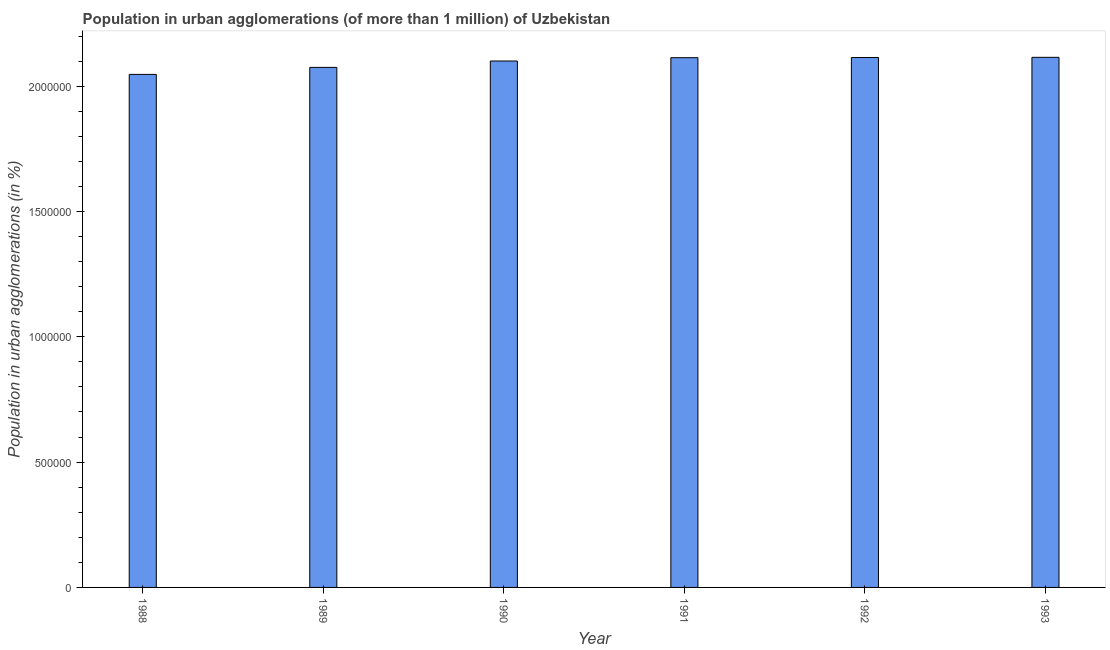Does the graph contain grids?
Ensure brevity in your answer.  No. What is the title of the graph?
Offer a terse response. Population in urban agglomerations (of more than 1 million) of Uzbekistan. What is the label or title of the Y-axis?
Keep it short and to the point. Population in urban agglomerations (in %). What is the population in urban agglomerations in 1988?
Keep it short and to the point. 2.05e+06. Across all years, what is the maximum population in urban agglomerations?
Your answer should be very brief. 2.12e+06. Across all years, what is the minimum population in urban agglomerations?
Your response must be concise. 2.05e+06. What is the sum of the population in urban agglomerations?
Provide a succinct answer. 1.26e+07. What is the difference between the population in urban agglomerations in 1991 and 1992?
Give a very brief answer. -700. What is the average population in urban agglomerations per year?
Offer a terse response. 2.09e+06. What is the median population in urban agglomerations?
Ensure brevity in your answer.  2.11e+06. In how many years, is the population in urban agglomerations greater than 1600000 %?
Keep it short and to the point. 6. Do a majority of the years between 1991 and 1989 (inclusive) have population in urban agglomerations greater than 1800000 %?
Keep it short and to the point. Yes. Is the population in urban agglomerations in 1988 less than that in 1990?
Your answer should be compact. Yes. Is the difference between the population in urban agglomerations in 1991 and 1992 greater than the difference between any two years?
Provide a short and direct response. No. What is the difference between the highest and the second highest population in urban agglomerations?
Your answer should be compact. 699. Is the sum of the population in urban agglomerations in 1990 and 1992 greater than the maximum population in urban agglomerations across all years?
Your answer should be very brief. Yes. What is the difference between the highest and the lowest population in urban agglomerations?
Give a very brief answer. 6.81e+04. In how many years, is the population in urban agglomerations greater than the average population in urban agglomerations taken over all years?
Provide a succinct answer. 4. How many bars are there?
Provide a short and direct response. 6. What is the difference between two consecutive major ticks on the Y-axis?
Offer a terse response. 5.00e+05. What is the Population in urban agglomerations (in %) of 1988?
Offer a terse response. 2.05e+06. What is the Population in urban agglomerations (in %) of 1989?
Offer a very short reply. 2.07e+06. What is the Population in urban agglomerations (in %) of 1990?
Offer a very short reply. 2.10e+06. What is the Population in urban agglomerations (in %) in 1991?
Give a very brief answer. 2.11e+06. What is the Population in urban agglomerations (in %) of 1992?
Provide a short and direct response. 2.11e+06. What is the Population in urban agglomerations (in %) in 1993?
Your response must be concise. 2.12e+06. What is the difference between the Population in urban agglomerations (in %) in 1988 and 1989?
Offer a terse response. -2.80e+04. What is the difference between the Population in urban agglomerations (in %) in 1988 and 1990?
Offer a very short reply. -5.34e+04. What is the difference between the Population in urban agglomerations (in %) in 1988 and 1991?
Your answer should be compact. -6.67e+04. What is the difference between the Population in urban agglomerations (in %) in 1988 and 1992?
Keep it short and to the point. -6.74e+04. What is the difference between the Population in urban agglomerations (in %) in 1988 and 1993?
Keep it short and to the point. -6.81e+04. What is the difference between the Population in urban agglomerations (in %) in 1989 and 1990?
Make the answer very short. -2.54e+04. What is the difference between the Population in urban agglomerations (in %) in 1989 and 1991?
Your response must be concise. -3.87e+04. What is the difference between the Population in urban agglomerations (in %) in 1989 and 1992?
Your answer should be compact. -3.94e+04. What is the difference between the Population in urban agglomerations (in %) in 1989 and 1993?
Your answer should be very brief. -4.01e+04. What is the difference between the Population in urban agglomerations (in %) in 1990 and 1991?
Provide a short and direct response. -1.33e+04. What is the difference between the Population in urban agglomerations (in %) in 1990 and 1992?
Offer a very short reply. -1.40e+04. What is the difference between the Population in urban agglomerations (in %) in 1990 and 1993?
Your response must be concise. -1.47e+04. What is the difference between the Population in urban agglomerations (in %) in 1991 and 1992?
Make the answer very short. -700. What is the difference between the Population in urban agglomerations (in %) in 1991 and 1993?
Offer a very short reply. -1399. What is the difference between the Population in urban agglomerations (in %) in 1992 and 1993?
Your answer should be very brief. -699. What is the ratio of the Population in urban agglomerations (in %) in 1988 to that in 1992?
Offer a terse response. 0.97. What is the ratio of the Population in urban agglomerations (in %) in 1988 to that in 1993?
Make the answer very short. 0.97. What is the ratio of the Population in urban agglomerations (in %) in 1989 to that in 1990?
Your response must be concise. 0.99. What is the ratio of the Population in urban agglomerations (in %) in 1989 to that in 1992?
Your answer should be compact. 0.98. What is the ratio of the Population in urban agglomerations (in %) in 1989 to that in 1993?
Make the answer very short. 0.98. What is the ratio of the Population in urban agglomerations (in %) in 1990 to that in 1991?
Provide a succinct answer. 0.99. What is the ratio of the Population in urban agglomerations (in %) in 1990 to that in 1992?
Your answer should be very brief. 0.99. What is the ratio of the Population in urban agglomerations (in %) in 1991 to that in 1993?
Ensure brevity in your answer.  1. 